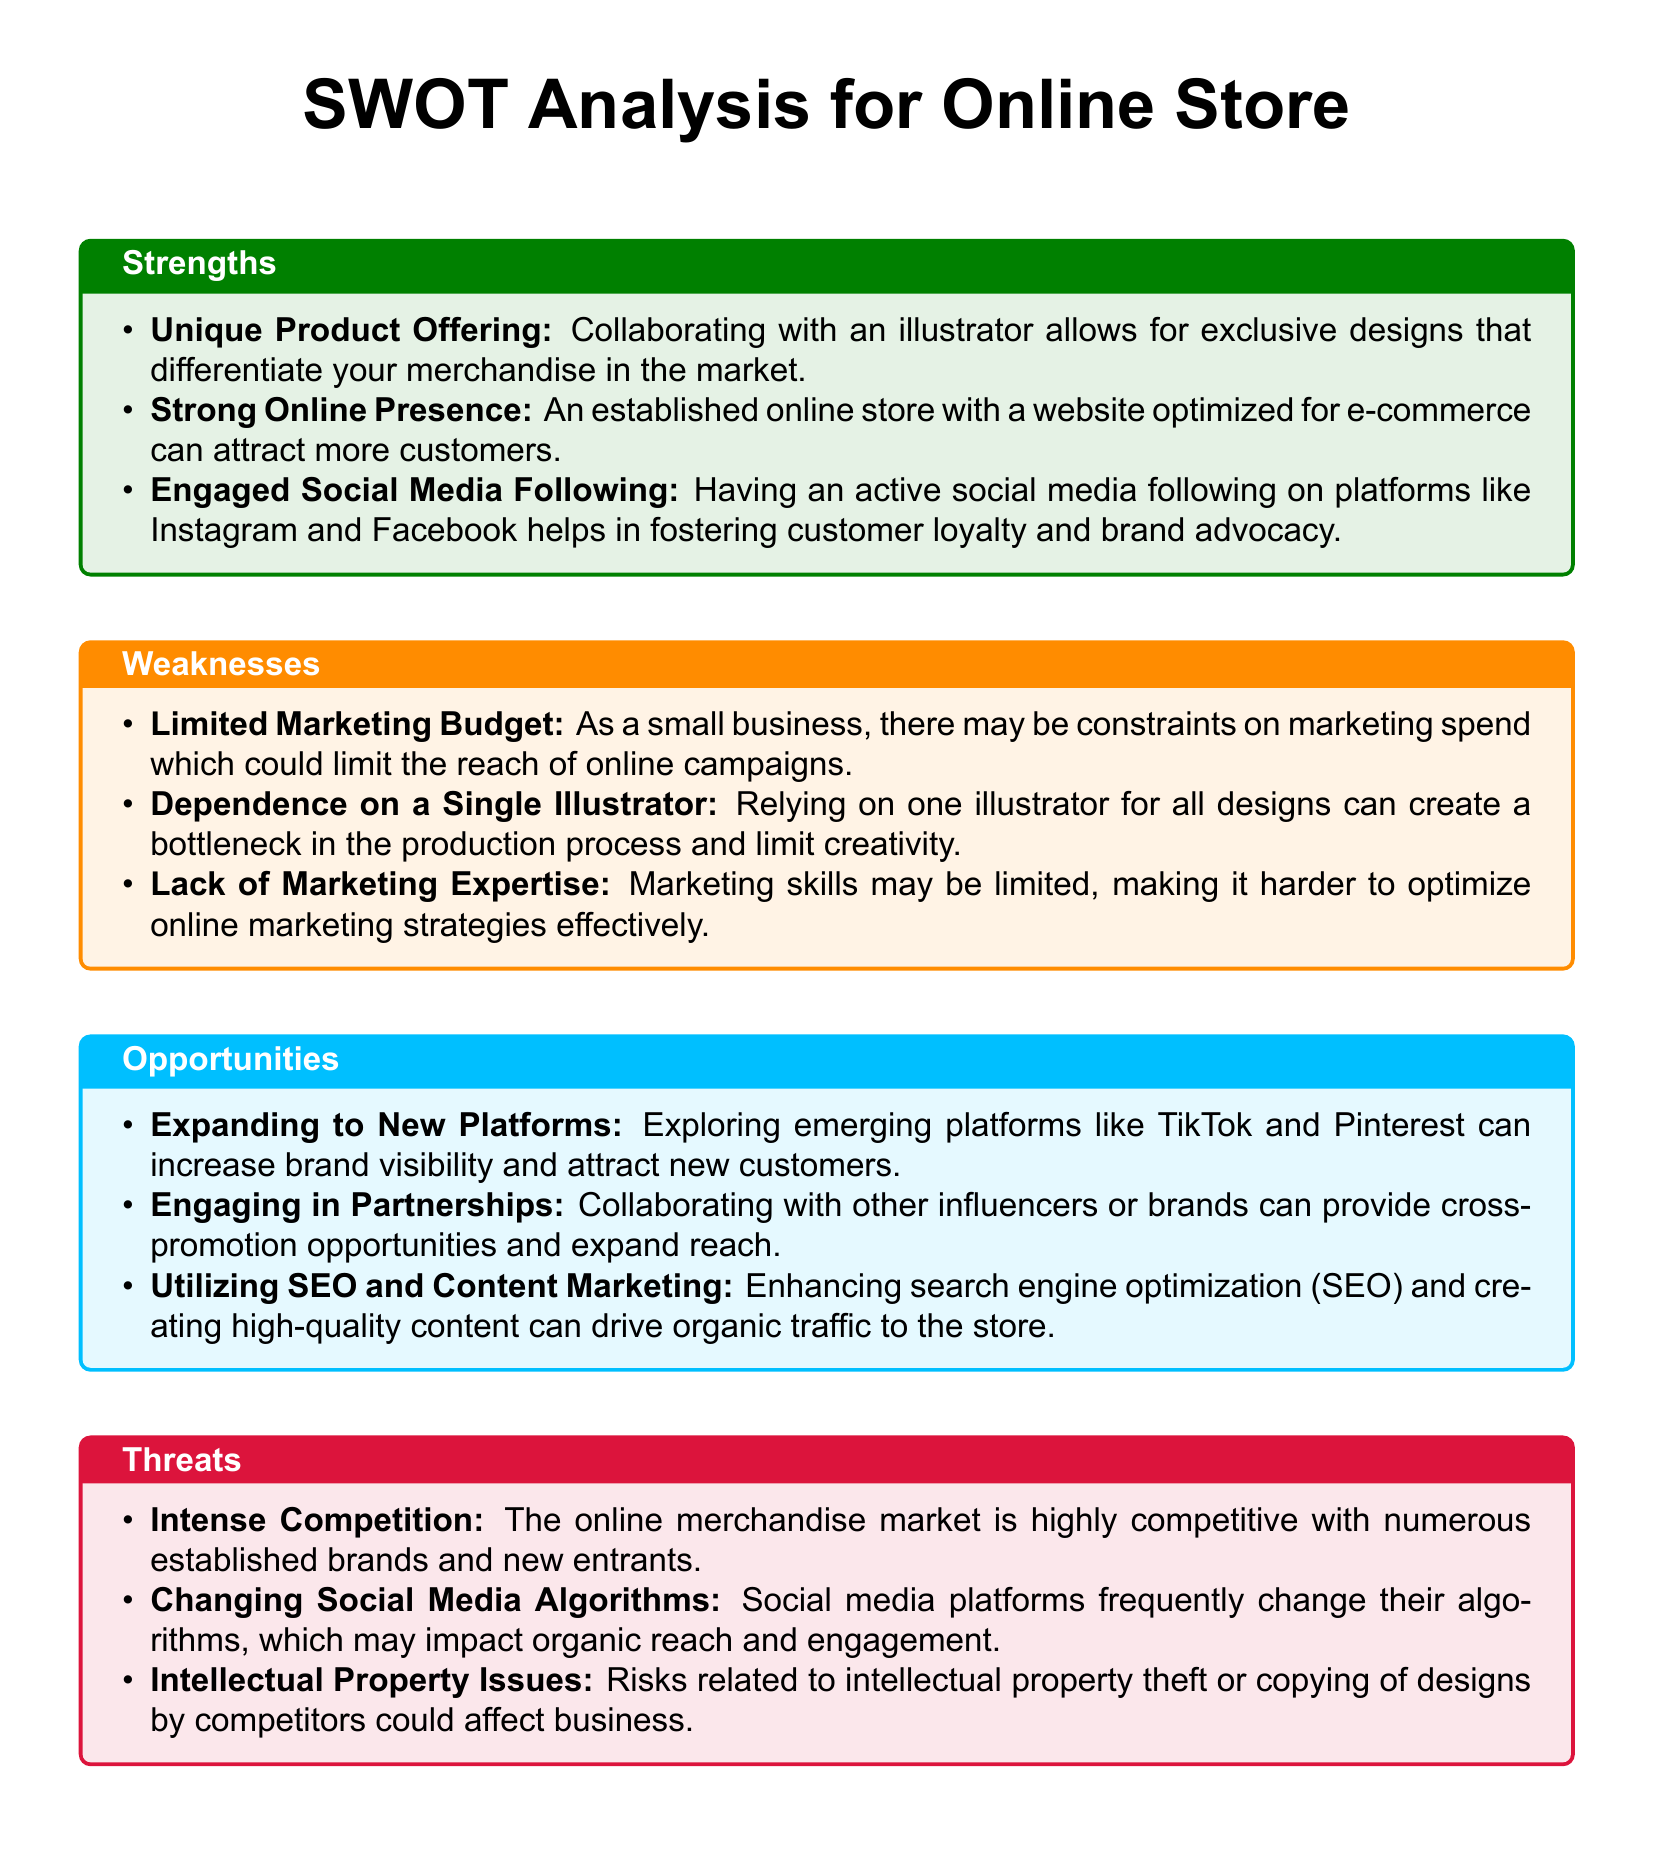What is the title of the document? The title of the document is stated at the beginning of the rendered content as "SWOT Analysis for Online Store."
Answer: SWOT Analysis for Online Store Which color represents Strengths in the document? The color used for strengths in the document is specified as green.
Answer: green What is a strength related to online presence? The specific strength mentioned states that "An established online store with a website optimized for e-commerce can attract more customers."
Answer: website optimized for e-commerce What is a weakness regarding marketing budgets? The document indicates that "there may be constraints on marketing spend which could limit the reach of online campaigns."
Answer: Limited Marketing Budget How many opportunities are listed in the document? By counting the items in the opportunities section, there are three listed opportunities provided.
Answer: 3 What is a threat linked to competition? The document highlights the threat of “The online merchandise market is highly competitive with numerous established brands and new entrants."
Answer: Intense Competition Which platform is mentioned as an opportunity for expansion? The document suggests "Exploring emerging platforms like TikTok and Pinterest can increase brand visibility."
Answer: TikTok and Pinterest What is a key aspect of the unique product offering? The importance of collaboration with an illustrator is emphasized for exclusive designs.
Answer: exclusive designs What indicates a weakness in marketing expertise? It states that limited marketing skills may hinder optimization of online strategies.
Answer: Lack of Marketing Expertise 